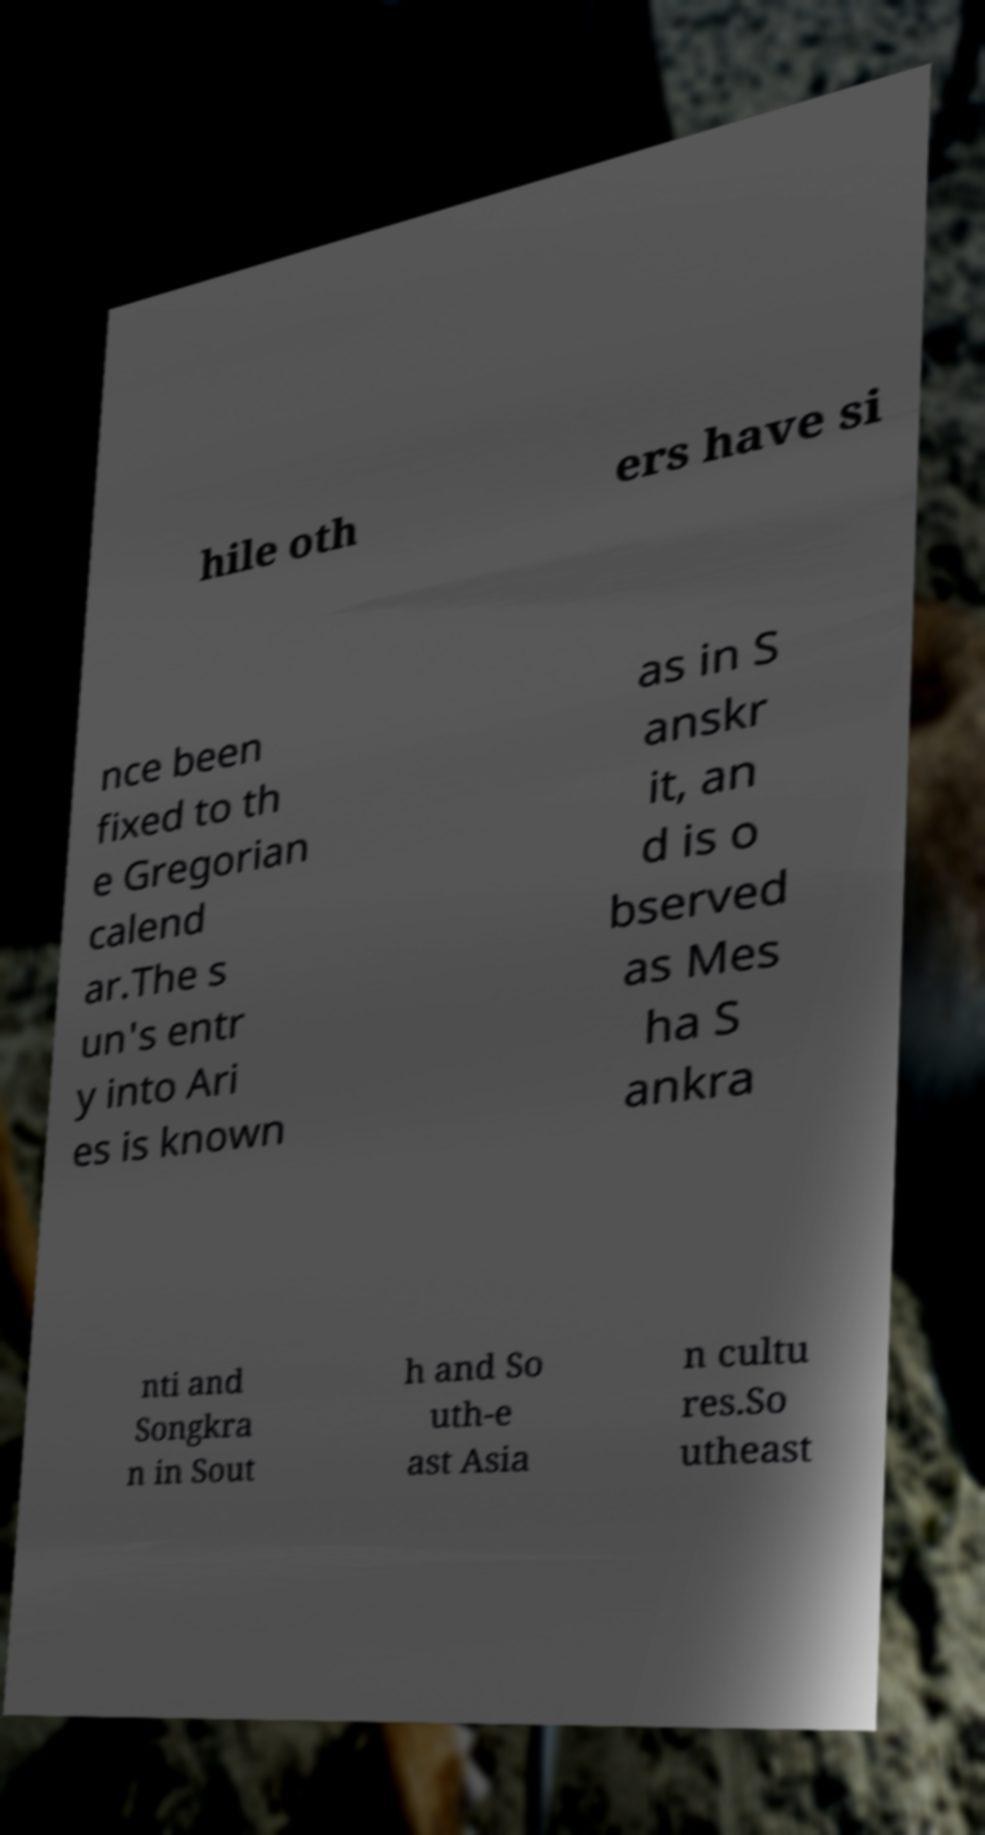I need the written content from this picture converted into text. Can you do that? hile oth ers have si nce been fixed to th e Gregorian calend ar.The s un's entr y into Ari es is known as in S anskr it, an d is o bserved as Mes ha S ankra nti and Songkra n in Sout h and So uth-e ast Asia n cultu res.So utheast 